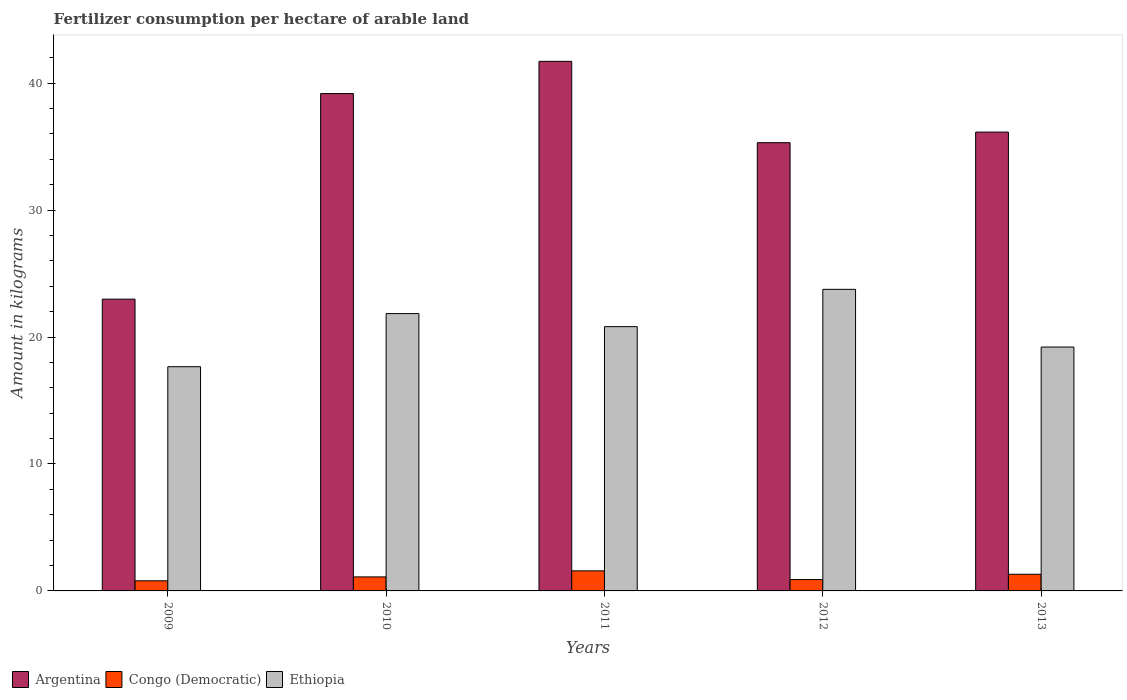Are the number of bars per tick equal to the number of legend labels?
Your answer should be very brief. Yes. How many bars are there on the 1st tick from the left?
Your response must be concise. 3. What is the label of the 2nd group of bars from the left?
Your answer should be very brief. 2010. In how many cases, is the number of bars for a given year not equal to the number of legend labels?
Your answer should be very brief. 0. What is the amount of fertilizer consumption in Congo (Democratic) in 2012?
Ensure brevity in your answer.  0.89. Across all years, what is the maximum amount of fertilizer consumption in Argentina?
Your answer should be compact. 41.72. Across all years, what is the minimum amount of fertilizer consumption in Argentina?
Provide a short and direct response. 22.98. In which year was the amount of fertilizer consumption in Argentina maximum?
Keep it short and to the point. 2011. What is the total amount of fertilizer consumption in Argentina in the graph?
Your answer should be compact. 175.34. What is the difference between the amount of fertilizer consumption in Ethiopia in 2012 and that in 2013?
Your answer should be compact. 4.54. What is the difference between the amount of fertilizer consumption in Ethiopia in 2010 and the amount of fertilizer consumption in Congo (Democratic) in 2013?
Offer a very short reply. 20.53. What is the average amount of fertilizer consumption in Argentina per year?
Provide a short and direct response. 35.07. In the year 2011, what is the difference between the amount of fertilizer consumption in Congo (Democratic) and amount of fertilizer consumption in Ethiopia?
Provide a succinct answer. -19.24. In how many years, is the amount of fertilizer consumption in Ethiopia greater than 14 kg?
Provide a short and direct response. 5. What is the ratio of the amount of fertilizer consumption in Ethiopia in 2009 to that in 2013?
Offer a terse response. 0.92. Is the amount of fertilizer consumption in Congo (Democratic) in 2010 less than that in 2013?
Offer a terse response. Yes. Is the difference between the amount of fertilizer consumption in Congo (Democratic) in 2011 and 2012 greater than the difference between the amount of fertilizer consumption in Ethiopia in 2011 and 2012?
Your answer should be very brief. Yes. What is the difference between the highest and the second highest amount of fertilizer consumption in Congo (Democratic)?
Offer a very short reply. 0.27. What is the difference between the highest and the lowest amount of fertilizer consumption in Argentina?
Ensure brevity in your answer.  18.73. What does the 2nd bar from the left in 2009 represents?
Your answer should be compact. Congo (Democratic). What does the 1st bar from the right in 2009 represents?
Make the answer very short. Ethiopia. Is it the case that in every year, the sum of the amount of fertilizer consumption in Argentina and amount of fertilizer consumption in Ethiopia is greater than the amount of fertilizer consumption in Congo (Democratic)?
Your answer should be compact. Yes. Are all the bars in the graph horizontal?
Your answer should be very brief. No. What is the difference between two consecutive major ticks on the Y-axis?
Your response must be concise. 10. Are the values on the major ticks of Y-axis written in scientific E-notation?
Offer a very short reply. No. How many legend labels are there?
Give a very brief answer. 3. What is the title of the graph?
Offer a terse response. Fertilizer consumption per hectare of arable land. What is the label or title of the Y-axis?
Offer a very short reply. Amount in kilograms. What is the Amount in kilograms of Argentina in 2009?
Keep it short and to the point. 22.98. What is the Amount in kilograms in Congo (Democratic) in 2009?
Keep it short and to the point. 0.8. What is the Amount in kilograms in Ethiopia in 2009?
Your answer should be compact. 17.66. What is the Amount in kilograms of Argentina in 2010?
Keep it short and to the point. 39.18. What is the Amount in kilograms of Congo (Democratic) in 2010?
Make the answer very short. 1.1. What is the Amount in kilograms of Ethiopia in 2010?
Offer a terse response. 21.85. What is the Amount in kilograms in Argentina in 2011?
Make the answer very short. 41.72. What is the Amount in kilograms of Congo (Democratic) in 2011?
Offer a terse response. 1.58. What is the Amount in kilograms of Ethiopia in 2011?
Offer a terse response. 20.82. What is the Amount in kilograms of Argentina in 2012?
Your answer should be compact. 35.31. What is the Amount in kilograms of Congo (Democratic) in 2012?
Your response must be concise. 0.89. What is the Amount in kilograms of Ethiopia in 2012?
Your answer should be very brief. 23.76. What is the Amount in kilograms in Argentina in 2013?
Offer a terse response. 36.15. What is the Amount in kilograms of Congo (Democratic) in 2013?
Keep it short and to the point. 1.31. What is the Amount in kilograms in Ethiopia in 2013?
Your answer should be compact. 19.21. Across all years, what is the maximum Amount in kilograms in Argentina?
Keep it short and to the point. 41.72. Across all years, what is the maximum Amount in kilograms in Congo (Democratic)?
Make the answer very short. 1.58. Across all years, what is the maximum Amount in kilograms in Ethiopia?
Offer a terse response. 23.76. Across all years, what is the minimum Amount in kilograms in Argentina?
Your response must be concise. 22.98. Across all years, what is the minimum Amount in kilograms of Congo (Democratic)?
Your answer should be very brief. 0.8. Across all years, what is the minimum Amount in kilograms in Ethiopia?
Provide a short and direct response. 17.66. What is the total Amount in kilograms in Argentina in the graph?
Give a very brief answer. 175.34. What is the total Amount in kilograms in Congo (Democratic) in the graph?
Give a very brief answer. 5.69. What is the total Amount in kilograms in Ethiopia in the graph?
Provide a succinct answer. 103.3. What is the difference between the Amount in kilograms of Argentina in 2009 and that in 2010?
Provide a short and direct response. -16.2. What is the difference between the Amount in kilograms in Congo (Democratic) in 2009 and that in 2010?
Keep it short and to the point. -0.31. What is the difference between the Amount in kilograms of Ethiopia in 2009 and that in 2010?
Make the answer very short. -4.18. What is the difference between the Amount in kilograms of Argentina in 2009 and that in 2011?
Keep it short and to the point. -18.73. What is the difference between the Amount in kilograms in Congo (Democratic) in 2009 and that in 2011?
Offer a terse response. -0.78. What is the difference between the Amount in kilograms of Ethiopia in 2009 and that in 2011?
Make the answer very short. -3.16. What is the difference between the Amount in kilograms in Argentina in 2009 and that in 2012?
Your response must be concise. -12.32. What is the difference between the Amount in kilograms of Congo (Democratic) in 2009 and that in 2012?
Your response must be concise. -0.1. What is the difference between the Amount in kilograms in Ethiopia in 2009 and that in 2012?
Offer a terse response. -6.1. What is the difference between the Amount in kilograms in Argentina in 2009 and that in 2013?
Keep it short and to the point. -13.16. What is the difference between the Amount in kilograms of Congo (Democratic) in 2009 and that in 2013?
Provide a short and direct response. -0.52. What is the difference between the Amount in kilograms of Ethiopia in 2009 and that in 2013?
Offer a very short reply. -1.55. What is the difference between the Amount in kilograms of Argentina in 2010 and that in 2011?
Offer a very short reply. -2.54. What is the difference between the Amount in kilograms in Congo (Democratic) in 2010 and that in 2011?
Ensure brevity in your answer.  -0.48. What is the difference between the Amount in kilograms of Ethiopia in 2010 and that in 2011?
Give a very brief answer. 1.03. What is the difference between the Amount in kilograms of Argentina in 2010 and that in 2012?
Provide a succinct answer. 3.87. What is the difference between the Amount in kilograms of Congo (Democratic) in 2010 and that in 2012?
Keep it short and to the point. 0.21. What is the difference between the Amount in kilograms in Ethiopia in 2010 and that in 2012?
Offer a terse response. -1.91. What is the difference between the Amount in kilograms in Argentina in 2010 and that in 2013?
Offer a very short reply. 3.04. What is the difference between the Amount in kilograms in Congo (Democratic) in 2010 and that in 2013?
Your answer should be compact. -0.21. What is the difference between the Amount in kilograms of Ethiopia in 2010 and that in 2013?
Offer a very short reply. 2.63. What is the difference between the Amount in kilograms in Argentina in 2011 and that in 2012?
Your response must be concise. 6.41. What is the difference between the Amount in kilograms in Congo (Democratic) in 2011 and that in 2012?
Offer a very short reply. 0.69. What is the difference between the Amount in kilograms of Ethiopia in 2011 and that in 2012?
Your answer should be very brief. -2.94. What is the difference between the Amount in kilograms in Argentina in 2011 and that in 2013?
Provide a succinct answer. 5.57. What is the difference between the Amount in kilograms of Congo (Democratic) in 2011 and that in 2013?
Make the answer very short. 0.27. What is the difference between the Amount in kilograms of Ethiopia in 2011 and that in 2013?
Your answer should be very brief. 1.61. What is the difference between the Amount in kilograms of Argentina in 2012 and that in 2013?
Your response must be concise. -0.84. What is the difference between the Amount in kilograms of Congo (Democratic) in 2012 and that in 2013?
Give a very brief answer. -0.42. What is the difference between the Amount in kilograms of Ethiopia in 2012 and that in 2013?
Keep it short and to the point. 4.54. What is the difference between the Amount in kilograms in Argentina in 2009 and the Amount in kilograms in Congo (Democratic) in 2010?
Give a very brief answer. 21.88. What is the difference between the Amount in kilograms of Argentina in 2009 and the Amount in kilograms of Ethiopia in 2010?
Provide a succinct answer. 1.14. What is the difference between the Amount in kilograms of Congo (Democratic) in 2009 and the Amount in kilograms of Ethiopia in 2010?
Offer a terse response. -21.05. What is the difference between the Amount in kilograms of Argentina in 2009 and the Amount in kilograms of Congo (Democratic) in 2011?
Your answer should be very brief. 21.4. What is the difference between the Amount in kilograms in Argentina in 2009 and the Amount in kilograms in Ethiopia in 2011?
Your response must be concise. 2.17. What is the difference between the Amount in kilograms of Congo (Democratic) in 2009 and the Amount in kilograms of Ethiopia in 2011?
Your answer should be very brief. -20.02. What is the difference between the Amount in kilograms in Argentina in 2009 and the Amount in kilograms in Congo (Democratic) in 2012?
Keep it short and to the point. 22.09. What is the difference between the Amount in kilograms in Argentina in 2009 and the Amount in kilograms in Ethiopia in 2012?
Provide a succinct answer. -0.77. What is the difference between the Amount in kilograms of Congo (Democratic) in 2009 and the Amount in kilograms of Ethiopia in 2012?
Your response must be concise. -22.96. What is the difference between the Amount in kilograms in Argentina in 2009 and the Amount in kilograms in Congo (Democratic) in 2013?
Ensure brevity in your answer.  21.67. What is the difference between the Amount in kilograms in Argentina in 2009 and the Amount in kilograms in Ethiopia in 2013?
Your answer should be very brief. 3.77. What is the difference between the Amount in kilograms of Congo (Democratic) in 2009 and the Amount in kilograms of Ethiopia in 2013?
Provide a succinct answer. -18.42. What is the difference between the Amount in kilograms in Argentina in 2010 and the Amount in kilograms in Congo (Democratic) in 2011?
Ensure brevity in your answer.  37.6. What is the difference between the Amount in kilograms in Argentina in 2010 and the Amount in kilograms in Ethiopia in 2011?
Your response must be concise. 18.36. What is the difference between the Amount in kilograms of Congo (Democratic) in 2010 and the Amount in kilograms of Ethiopia in 2011?
Your response must be concise. -19.71. What is the difference between the Amount in kilograms in Argentina in 2010 and the Amount in kilograms in Congo (Democratic) in 2012?
Give a very brief answer. 38.29. What is the difference between the Amount in kilograms of Argentina in 2010 and the Amount in kilograms of Ethiopia in 2012?
Offer a very short reply. 15.42. What is the difference between the Amount in kilograms of Congo (Democratic) in 2010 and the Amount in kilograms of Ethiopia in 2012?
Give a very brief answer. -22.65. What is the difference between the Amount in kilograms of Argentina in 2010 and the Amount in kilograms of Congo (Democratic) in 2013?
Keep it short and to the point. 37.87. What is the difference between the Amount in kilograms in Argentina in 2010 and the Amount in kilograms in Ethiopia in 2013?
Provide a short and direct response. 19.97. What is the difference between the Amount in kilograms in Congo (Democratic) in 2010 and the Amount in kilograms in Ethiopia in 2013?
Offer a very short reply. -18.11. What is the difference between the Amount in kilograms in Argentina in 2011 and the Amount in kilograms in Congo (Democratic) in 2012?
Provide a succinct answer. 40.82. What is the difference between the Amount in kilograms in Argentina in 2011 and the Amount in kilograms in Ethiopia in 2012?
Keep it short and to the point. 17.96. What is the difference between the Amount in kilograms of Congo (Democratic) in 2011 and the Amount in kilograms of Ethiopia in 2012?
Keep it short and to the point. -22.18. What is the difference between the Amount in kilograms in Argentina in 2011 and the Amount in kilograms in Congo (Democratic) in 2013?
Give a very brief answer. 40.4. What is the difference between the Amount in kilograms in Argentina in 2011 and the Amount in kilograms in Ethiopia in 2013?
Your answer should be compact. 22.5. What is the difference between the Amount in kilograms in Congo (Democratic) in 2011 and the Amount in kilograms in Ethiopia in 2013?
Provide a succinct answer. -17.63. What is the difference between the Amount in kilograms in Argentina in 2012 and the Amount in kilograms in Congo (Democratic) in 2013?
Provide a succinct answer. 34. What is the difference between the Amount in kilograms of Argentina in 2012 and the Amount in kilograms of Ethiopia in 2013?
Your answer should be compact. 16.1. What is the difference between the Amount in kilograms of Congo (Democratic) in 2012 and the Amount in kilograms of Ethiopia in 2013?
Offer a very short reply. -18.32. What is the average Amount in kilograms of Argentina per year?
Offer a very short reply. 35.07. What is the average Amount in kilograms of Congo (Democratic) per year?
Provide a succinct answer. 1.14. What is the average Amount in kilograms in Ethiopia per year?
Your answer should be compact. 20.66. In the year 2009, what is the difference between the Amount in kilograms in Argentina and Amount in kilograms in Congo (Democratic)?
Ensure brevity in your answer.  22.19. In the year 2009, what is the difference between the Amount in kilograms in Argentina and Amount in kilograms in Ethiopia?
Your answer should be compact. 5.32. In the year 2009, what is the difference between the Amount in kilograms of Congo (Democratic) and Amount in kilograms of Ethiopia?
Your answer should be very brief. -16.87. In the year 2010, what is the difference between the Amount in kilograms in Argentina and Amount in kilograms in Congo (Democratic)?
Keep it short and to the point. 38.08. In the year 2010, what is the difference between the Amount in kilograms in Argentina and Amount in kilograms in Ethiopia?
Make the answer very short. 17.33. In the year 2010, what is the difference between the Amount in kilograms of Congo (Democratic) and Amount in kilograms of Ethiopia?
Ensure brevity in your answer.  -20.74. In the year 2011, what is the difference between the Amount in kilograms of Argentina and Amount in kilograms of Congo (Democratic)?
Offer a terse response. 40.14. In the year 2011, what is the difference between the Amount in kilograms of Argentina and Amount in kilograms of Ethiopia?
Provide a short and direct response. 20.9. In the year 2011, what is the difference between the Amount in kilograms of Congo (Democratic) and Amount in kilograms of Ethiopia?
Give a very brief answer. -19.24. In the year 2012, what is the difference between the Amount in kilograms in Argentina and Amount in kilograms in Congo (Democratic)?
Ensure brevity in your answer.  34.41. In the year 2012, what is the difference between the Amount in kilograms in Argentina and Amount in kilograms in Ethiopia?
Keep it short and to the point. 11.55. In the year 2012, what is the difference between the Amount in kilograms of Congo (Democratic) and Amount in kilograms of Ethiopia?
Your response must be concise. -22.86. In the year 2013, what is the difference between the Amount in kilograms of Argentina and Amount in kilograms of Congo (Democratic)?
Give a very brief answer. 34.83. In the year 2013, what is the difference between the Amount in kilograms of Argentina and Amount in kilograms of Ethiopia?
Your answer should be very brief. 16.93. In the year 2013, what is the difference between the Amount in kilograms in Congo (Democratic) and Amount in kilograms in Ethiopia?
Your answer should be compact. -17.9. What is the ratio of the Amount in kilograms of Argentina in 2009 to that in 2010?
Offer a very short reply. 0.59. What is the ratio of the Amount in kilograms of Congo (Democratic) in 2009 to that in 2010?
Your answer should be compact. 0.72. What is the ratio of the Amount in kilograms of Ethiopia in 2009 to that in 2010?
Your answer should be very brief. 0.81. What is the ratio of the Amount in kilograms in Argentina in 2009 to that in 2011?
Give a very brief answer. 0.55. What is the ratio of the Amount in kilograms in Congo (Democratic) in 2009 to that in 2011?
Keep it short and to the point. 0.5. What is the ratio of the Amount in kilograms of Ethiopia in 2009 to that in 2011?
Make the answer very short. 0.85. What is the ratio of the Amount in kilograms in Argentina in 2009 to that in 2012?
Make the answer very short. 0.65. What is the ratio of the Amount in kilograms of Congo (Democratic) in 2009 to that in 2012?
Your response must be concise. 0.89. What is the ratio of the Amount in kilograms of Ethiopia in 2009 to that in 2012?
Your answer should be compact. 0.74. What is the ratio of the Amount in kilograms in Argentina in 2009 to that in 2013?
Make the answer very short. 0.64. What is the ratio of the Amount in kilograms in Congo (Democratic) in 2009 to that in 2013?
Your answer should be very brief. 0.61. What is the ratio of the Amount in kilograms of Ethiopia in 2009 to that in 2013?
Provide a succinct answer. 0.92. What is the ratio of the Amount in kilograms of Argentina in 2010 to that in 2011?
Give a very brief answer. 0.94. What is the ratio of the Amount in kilograms in Congo (Democratic) in 2010 to that in 2011?
Your response must be concise. 0.7. What is the ratio of the Amount in kilograms in Ethiopia in 2010 to that in 2011?
Your response must be concise. 1.05. What is the ratio of the Amount in kilograms of Argentina in 2010 to that in 2012?
Give a very brief answer. 1.11. What is the ratio of the Amount in kilograms of Congo (Democratic) in 2010 to that in 2012?
Your response must be concise. 1.23. What is the ratio of the Amount in kilograms of Ethiopia in 2010 to that in 2012?
Give a very brief answer. 0.92. What is the ratio of the Amount in kilograms of Argentina in 2010 to that in 2013?
Ensure brevity in your answer.  1.08. What is the ratio of the Amount in kilograms in Congo (Democratic) in 2010 to that in 2013?
Give a very brief answer. 0.84. What is the ratio of the Amount in kilograms of Ethiopia in 2010 to that in 2013?
Your answer should be very brief. 1.14. What is the ratio of the Amount in kilograms in Argentina in 2011 to that in 2012?
Keep it short and to the point. 1.18. What is the ratio of the Amount in kilograms in Congo (Democratic) in 2011 to that in 2012?
Your answer should be compact. 1.77. What is the ratio of the Amount in kilograms in Ethiopia in 2011 to that in 2012?
Offer a terse response. 0.88. What is the ratio of the Amount in kilograms of Argentina in 2011 to that in 2013?
Provide a short and direct response. 1.15. What is the ratio of the Amount in kilograms of Congo (Democratic) in 2011 to that in 2013?
Offer a terse response. 1.2. What is the ratio of the Amount in kilograms of Ethiopia in 2011 to that in 2013?
Your answer should be compact. 1.08. What is the ratio of the Amount in kilograms of Argentina in 2012 to that in 2013?
Your answer should be compact. 0.98. What is the ratio of the Amount in kilograms of Congo (Democratic) in 2012 to that in 2013?
Offer a very short reply. 0.68. What is the ratio of the Amount in kilograms in Ethiopia in 2012 to that in 2013?
Keep it short and to the point. 1.24. What is the difference between the highest and the second highest Amount in kilograms of Argentina?
Your response must be concise. 2.54. What is the difference between the highest and the second highest Amount in kilograms in Congo (Democratic)?
Give a very brief answer. 0.27. What is the difference between the highest and the second highest Amount in kilograms of Ethiopia?
Ensure brevity in your answer.  1.91. What is the difference between the highest and the lowest Amount in kilograms of Argentina?
Your response must be concise. 18.73. What is the difference between the highest and the lowest Amount in kilograms of Congo (Democratic)?
Give a very brief answer. 0.78. What is the difference between the highest and the lowest Amount in kilograms in Ethiopia?
Provide a succinct answer. 6.1. 